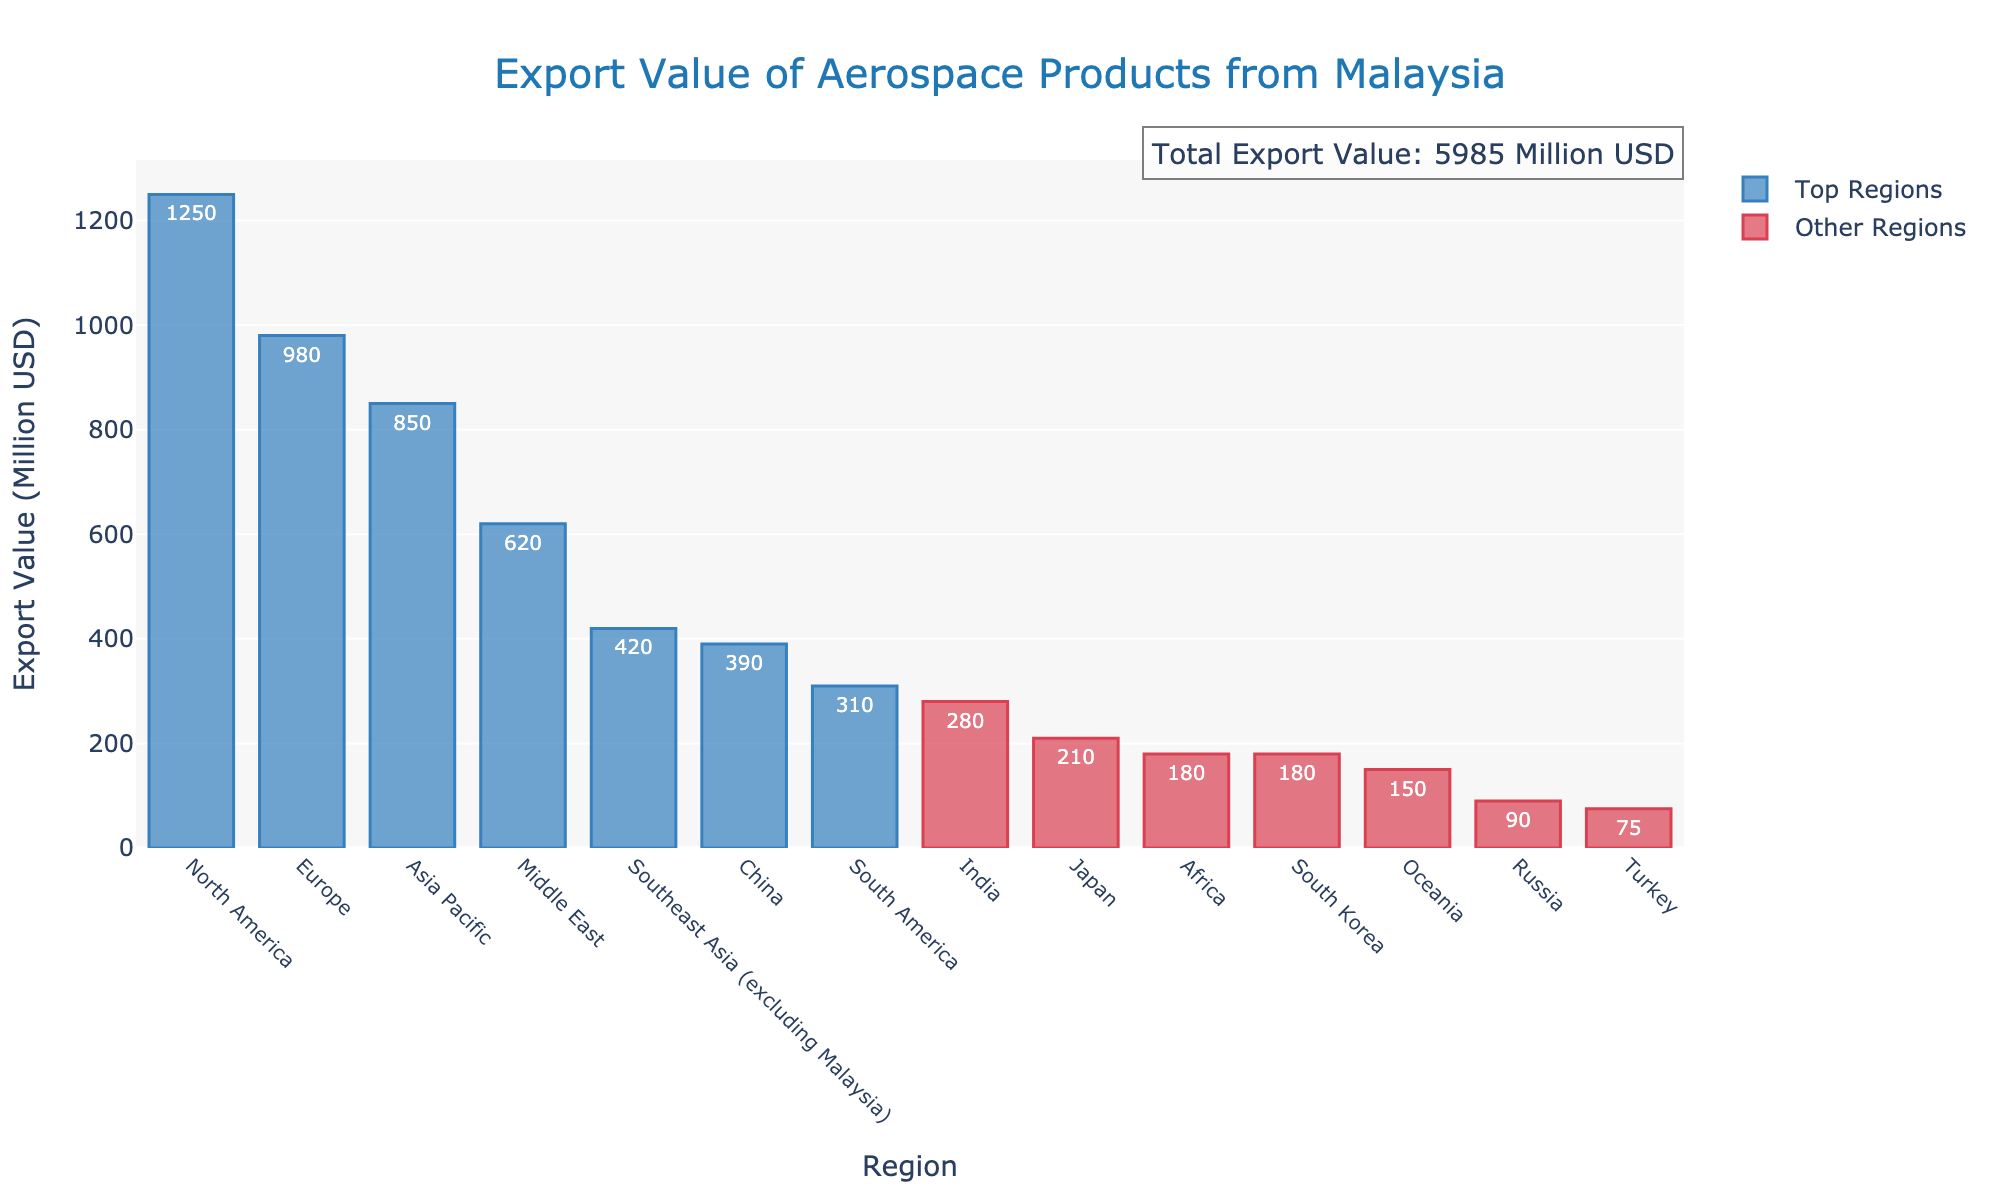What is the region with the highest export value? The region with the highest export value has the tallest bar in the bar chart. Looking at the chart, the tallest bar represents North America.
Answer: North America Which regions have export values less than 200 million USD? To answer this, identify the bars that are visually shorter and have a height indicating less than 200 million USD. The regions with such values are Africa, Oceania, Russia, and Turkey.
Answer: Africa, Oceania, Russia, Turkey How much more is Malaysia's aerospace export value to North America compared to South America? First, find the export values for North America and South America from the chart. North America has 1250 million USD, and South America has 310 million USD. Subtract South America's value from North America's value: 1250 - 310.
Answer: 940 million USD What is the total export value for North America, Europe, and Asia Pacific combined? To find the total, sum the export values of these regions. North America: 1250 million USD, Europe: 980 million USD, Asia Pacific: 850 million USD. So, 1250 + 980 + 850.
Answer: 3080 million USD Which regions have higher export values than Southeast Asia (excluding Malaysia)? Find the export value of Southeast Asia (420 million USD) and locate the regions with higher values. These regions are North America, Europe, Asia Pacific, and the Middle East.
Answer: North America, Europe, Asia Pacific, Middle East What is the difference in export values between China and Japan? From the chart, China has 390 million USD, and Japan has 210 million USD. Subtract Japan's value from China's value: 390 - 210.
Answer: 180 million USD How does the export value to India compare to that of South Korea? Look at the chart to find the export values for India (280 million USD) and South Korea (180 million USD). India has a higher export value than South Korea.
Answer: India has a higher export value Which region has the smallest export value, and what is that value? Identify the shortest bar in the bar chart, which represents the region with the smallest export value. That region is Turkey, with a value of 75 million USD.
Answer: Turkey, 75 million USD What is the average export value for the regions displayed? Sum the export values of all regions and divide by the number of regions. The total export value is 5885 million USD, and there are 14 regions. So, 5885 / 14.
Answer: Approximately 420.36 million USD 